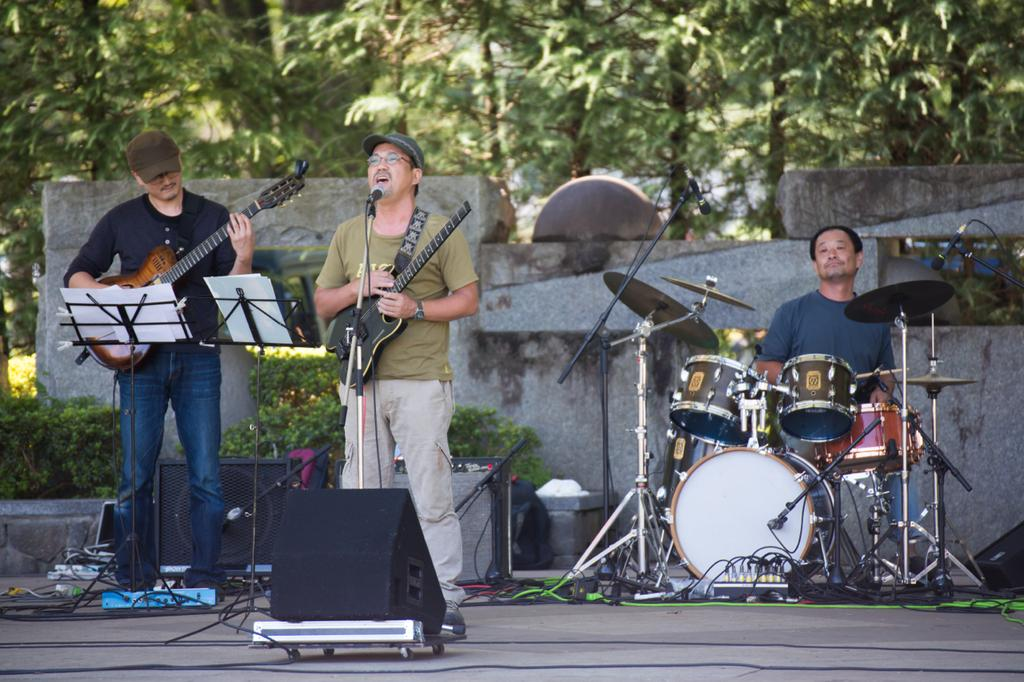How many people are in the image? There are three persons in the image. What are the people holding in the image? Each person is holding a musical instrument. What can be seen in the background of the image? There are trees and plants in the background of the image. Can you see any jellyfish in the image? No, there are no jellyfish present in the image. Are the people wearing masks while playing their instruments? There is no mention of masks in the image, so we cannot determine if the people are wearing them. 